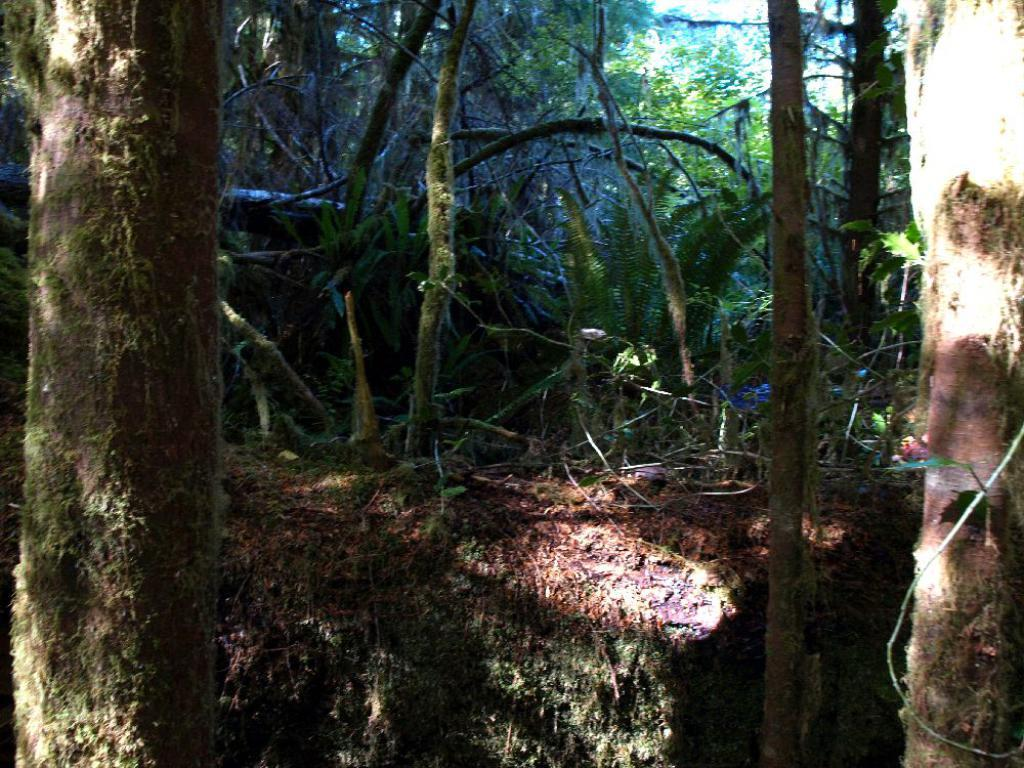What is the possible location from where the image was taken? The image might be taken from outside the city. What type of natural elements can be seen in the image? There are trees and plants in the image. What kind of terrain is visible at the bottom of the image? There is a land with stones visible at the bottom of the image. Who is the manager of the vest in the image? There is no manager or vest present in the image. 